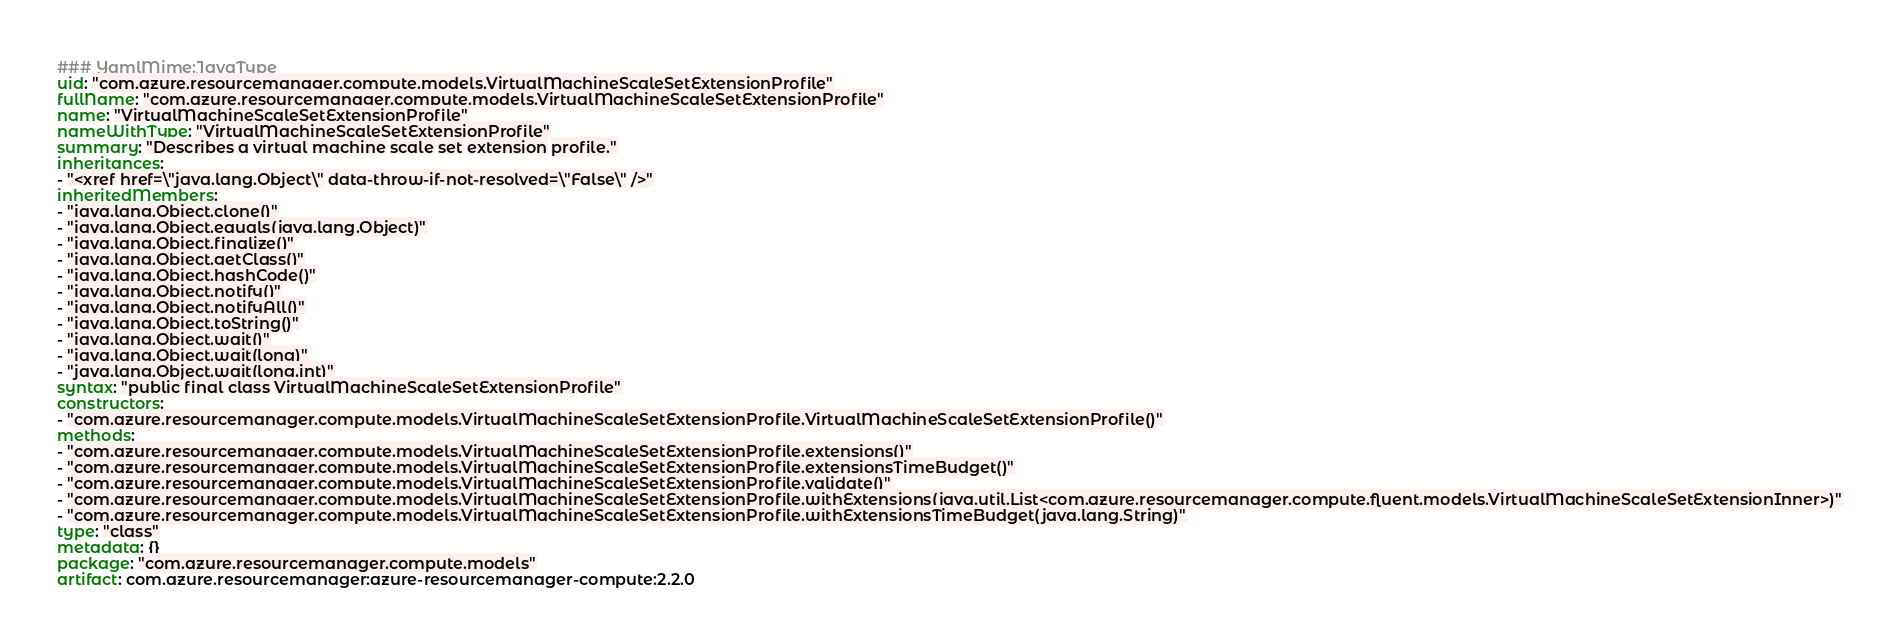<code> <loc_0><loc_0><loc_500><loc_500><_YAML_>### YamlMime:JavaType
uid: "com.azure.resourcemanager.compute.models.VirtualMachineScaleSetExtensionProfile"
fullName: "com.azure.resourcemanager.compute.models.VirtualMachineScaleSetExtensionProfile"
name: "VirtualMachineScaleSetExtensionProfile"
nameWithType: "VirtualMachineScaleSetExtensionProfile"
summary: "Describes a virtual machine scale set extension profile."
inheritances:
- "<xref href=\"java.lang.Object\" data-throw-if-not-resolved=\"False\" />"
inheritedMembers:
- "java.lang.Object.clone()"
- "java.lang.Object.equals(java.lang.Object)"
- "java.lang.Object.finalize()"
- "java.lang.Object.getClass()"
- "java.lang.Object.hashCode()"
- "java.lang.Object.notify()"
- "java.lang.Object.notifyAll()"
- "java.lang.Object.toString()"
- "java.lang.Object.wait()"
- "java.lang.Object.wait(long)"
- "java.lang.Object.wait(long,int)"
syntax: "public final class VirtualMachineScaleSetExtensionProfile"
constructors:
- "com.azure.resourcemanager.compute.models.VirtualMachineScaleSetExtensionProfile.VirtualMachineScaleSetExtensionProfile()"
methods:
- "com.azure.resourcemanager.compute.models.VirtualMachineScaleSetExtensionProfile.extensions()"
- "com.azure.resourcemanager.compute.models.VirtualMachineScaleSetExtensionProfile.extensionsTimeBudget()"
- "com.azure.resourcemanager.compute.models.VirtualMachineScaleSetExtensionProfile.validate()"
- "com.azure.resourcemanager.compute.models.VirtualMachineScaleSetExtensionProfile.withExtensions(java.util.List<com.azure.resourcemanager.compute.fluent.models.VirtualMachineScaleSetExtensionInner>)"
- "com.azure.resourcemanager.compute.models.VirtualMachineScaleSetExtensionProfile.withExtensionsTimeBudget(java.lang.String)"
type: "class"
metadata: {}
package: "com.azure.resourcemanager.compute.models"
artifact: com.azure.resourcemanager:azure-resourcemanager-compute:2.2.0
</code> 